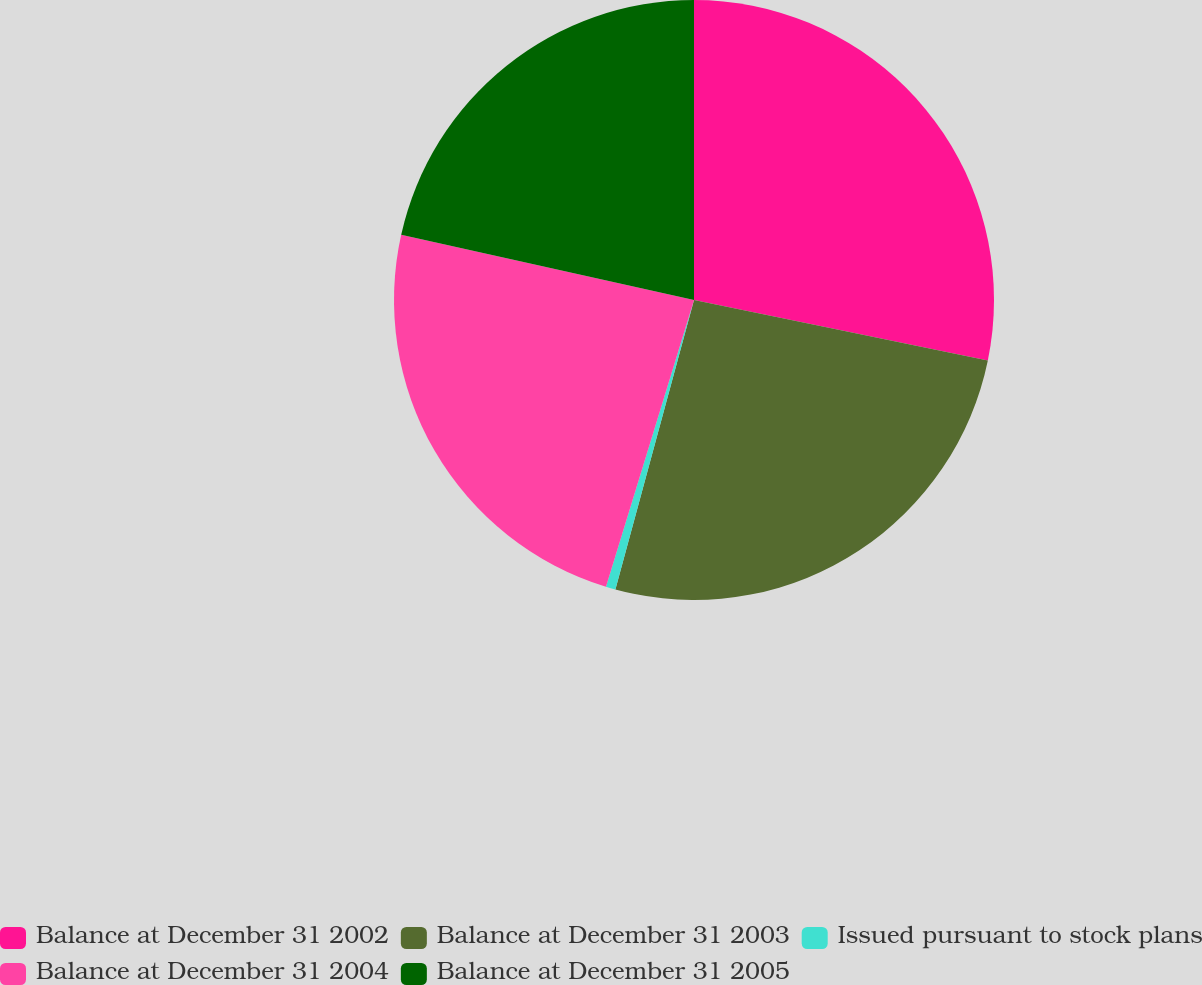Convert chart to OTSL. <chart><loc_0><loc_0><loc_500><loc_500><pie_chart><fcel>Balance at December 31 2002<fcel>Balance at December 31 2003<fcel>Issued pursuant to stock plans<fcel>Balance at December 31 2004<fcel>Balance at December 31 2005<nl><fcel>28.23%<fcel>25.99%<fcel>0.52%<fcel>23.75%<fcel>21.51%<nl></chart> 